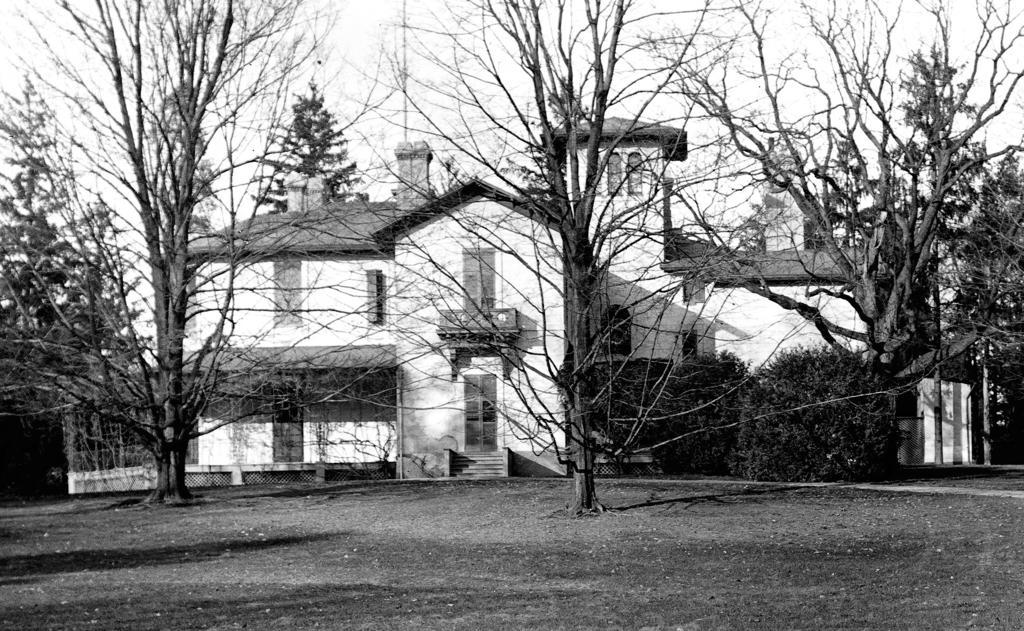In one or two sentences, can you explain what this image depicts? In this picture we can see a ground, here we can see a building, trees and we can see sky in the background. 